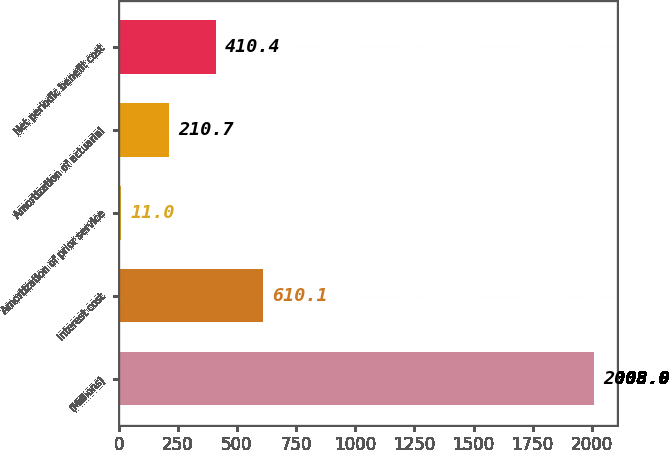Convert chart to OTSL. <chart><loc_0><loc_0><loc_500><loc_500><bar_chart><fcel>(Millions)<fcel>Interest cost<fcel>Amortization of prior service<fcel>Amortization of actuarial<fcel>Net periodic benefit cost<nl><fcel>2008<fcel>610.1<fcel>11<fcel>210.7<fcel>410.4<nl></chart> 